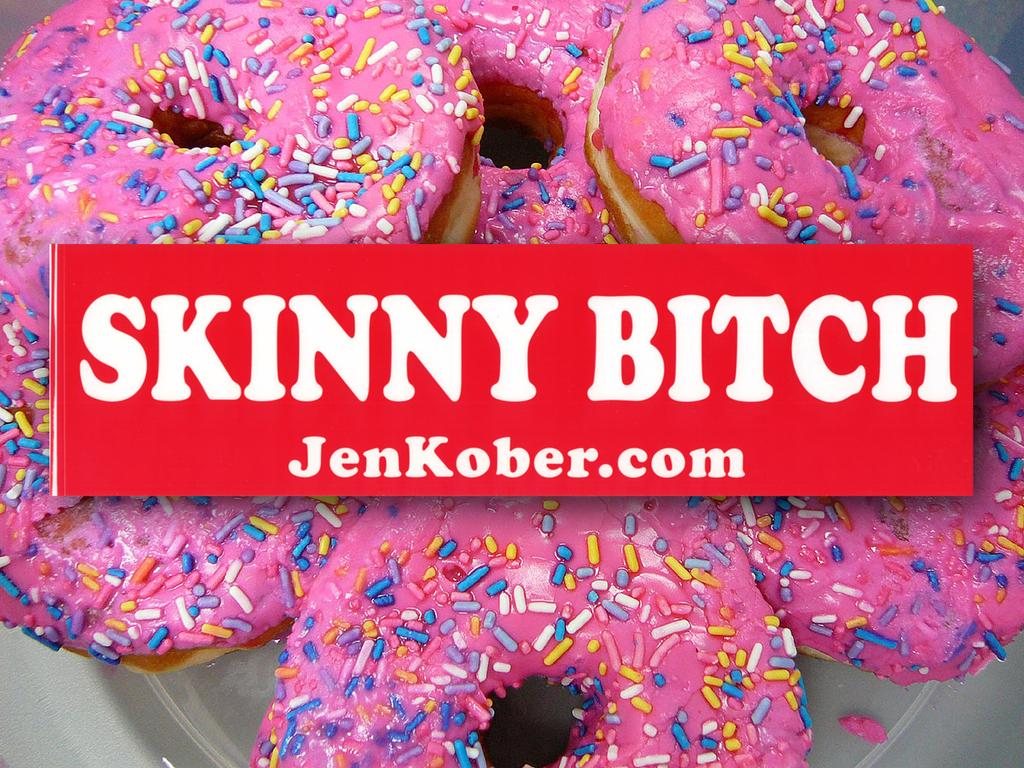What type of food is on the plate in the image? There are doughnuts on a plate in the image. What color is the plate? The plate is white. What can be seen in the image besides the plate of doughnuts? There is a red-colored name board in the image. What is written on the name board? The name board has some text on it. Can you see an owl sitting on the doughnuts in the image? No, there is no owl present in the image. Is there a dog visible near the name board in the image? No, there is no dog present in the image. 